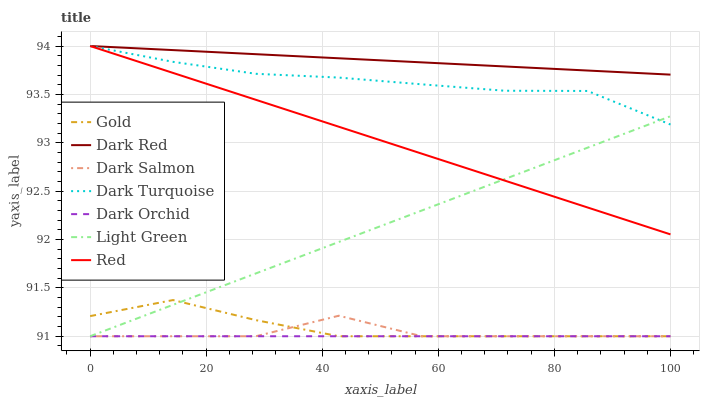Does Dark Orchid have the minimum area under the curve?
Answer yes or no. Yes. Does Dark Red have the maximum area under the curve?
Answer yes or no. Yes. Does Dark Salmon have the minimum area under the curve?
Answer yes or no. No. Does Dark Salmon have the maximum area under the curve?
Answer yes or no. No. Is Dark Orchid the smoothest?
Answer yes or no. Yes. Is Dark Salmon the roughest?
Answer yes or no. Yes. Is Dark Red the smoothest?
Answer yes or no. No. Is Dark Red the roughest?
Answer yes or no. No. Does Gold have the lowest value?
Answer yes or no. Yes. Does Dark Red have the lowest value?
Answer yes or no. No. Does Red have the highest value?
Answer yes or no. Yes. Does Dark Salmon have the highest value?
Answer yes or no. No. Is Dark Salmon less than Dark Turquoise?
Answer yes or no. Yes. Is Dark Turquoise greater than Dark Salmon?
Answer yes or no. Yes. Does Dark Orchid intersect Dark Salmon?
Answer yes or no. Yes. Is Dark Orchid less than Dark Salmon?
Answer yes or no. No. Is Dark Orchid greater than Dark Salmon?
Answer yes or no. No. Does Dark Salmon intersect Dark Turquoise?
Answer yes or no. No. 